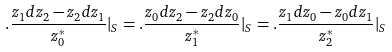Convert formula to latex. <formula><loc_0><loc_0><loc_500><loc_500>. \frac { z _ { 1 } d z _ { 2 } - z _ { 2 } d z _ { 1 } } { z _ { 0 } ^ { * } } | _ { S } = . \frac { z _ { 0 } d z _ { 2 } - z _ { 2 } d z _ { 0 } } { z _ { 1 } ^ { * } } | _ { S } = . \frac { z _ { 1 } d z _ { 0 } - z _ { 0 } d z _ { 1 } } { z _ { 2 } ^ { * } } | _ { S }</formula> 